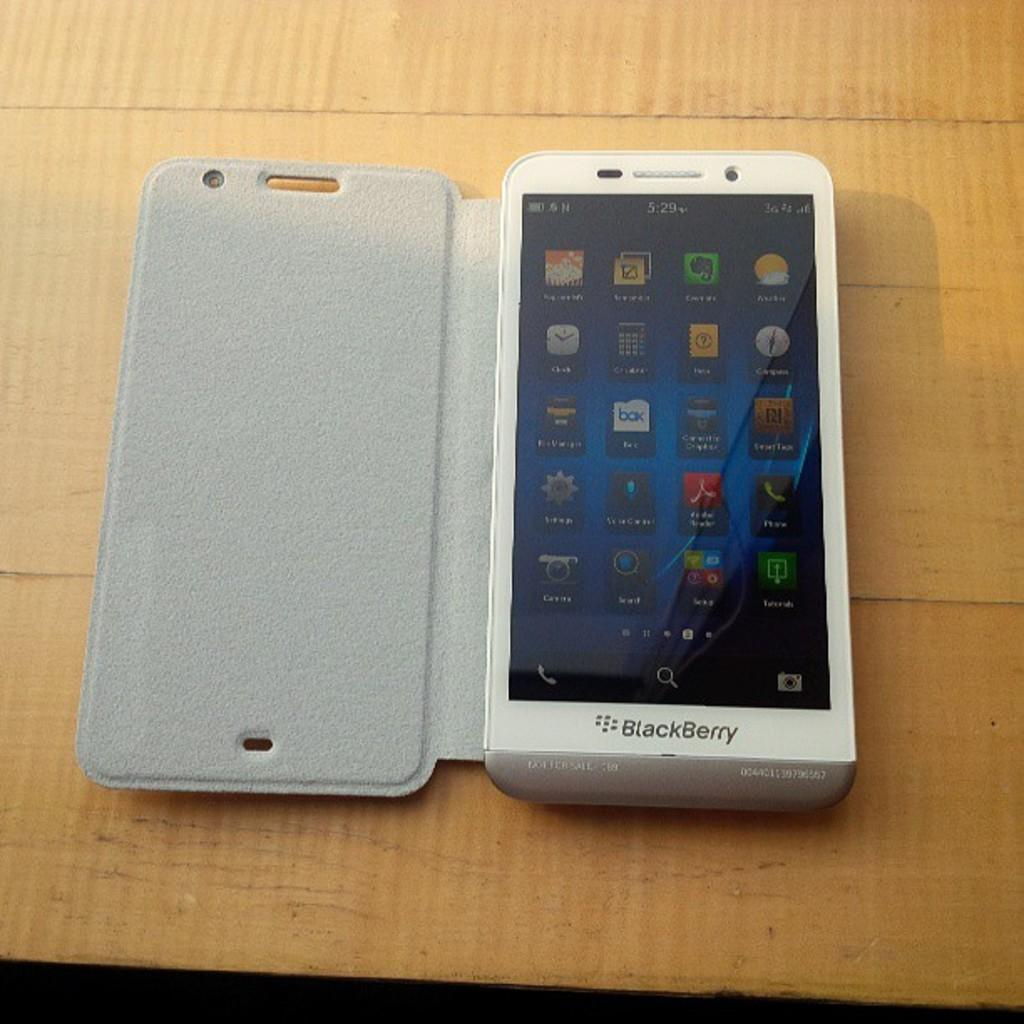<image>
Provide a brief description of the given image. The white cell phone is actually one of the newer BlackBerry smartphones and it has 20 apps on the home screen. 